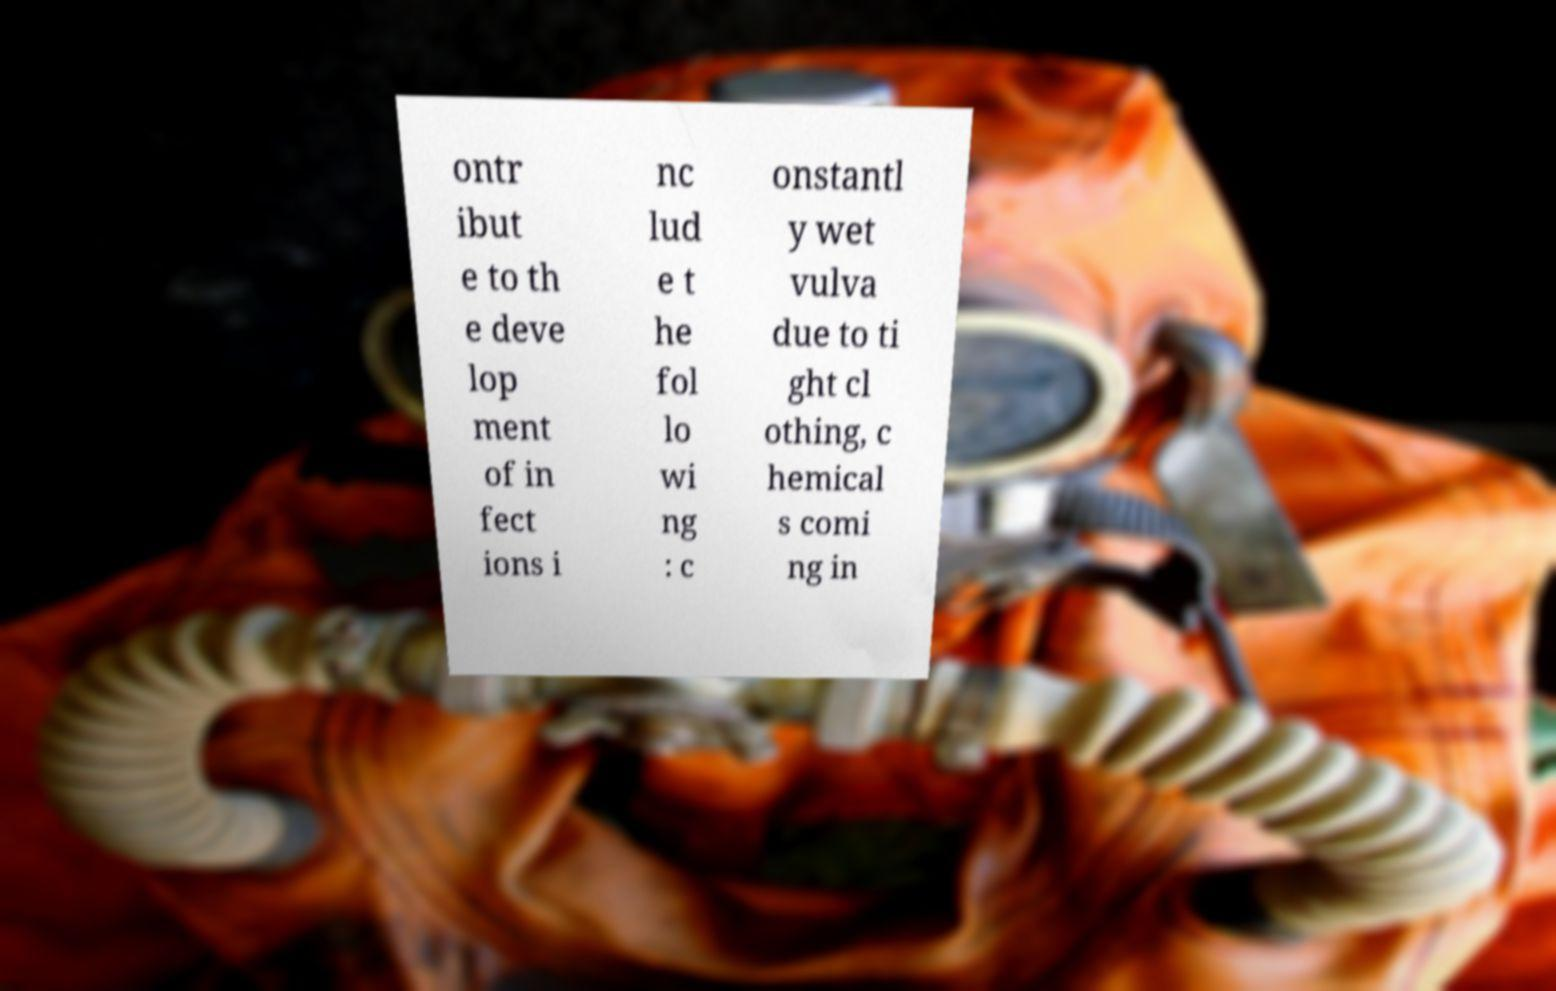I need the written content from this picture converted into text. Can you do that? ontr ibut e to th e deve lop ment of in fect ions i nc lud e t he fol lo wi ng : c onstantl y wet vulva due to ti ght cl othing, c hemical s comi ng in 